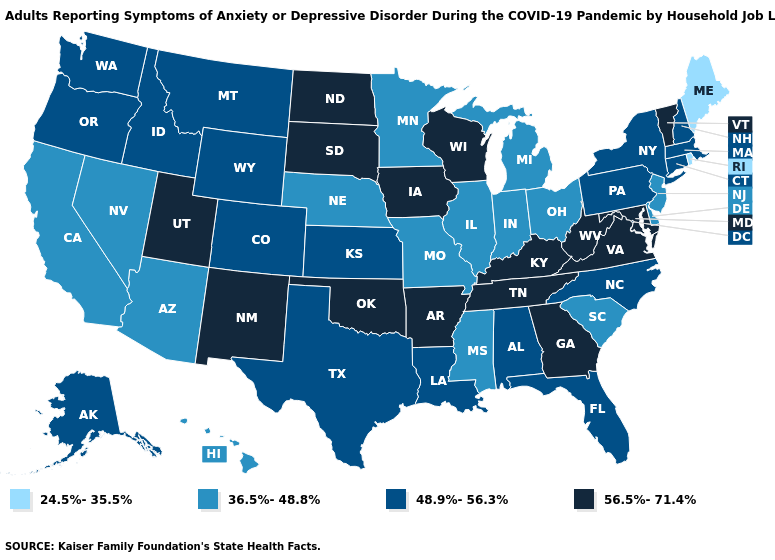What is the highest value in the USA?
Be succinct. 56.5%-71.4%. Name the states that have a value in the range 48.9%-56.3%?
Give a very brief answer. Alabama, Alaska, Colorado, Connecticut, Florida, Idaho, Kansas, Louisiana, Massachusetts, Montana, New Hampshire, New York, North Carolina, Oregon, Pennsylvania, Texas, Washington, Wyoming. Which states have the lowest value in the South?
Give a very brief answer. Delaware, Mississippi, South Carolina. Does the first symbol in the legend represent the smallest category?
Keep it brief. Yes. How many symbols are there in the legend?
Short answer required. 4. What is the highest value in the South ?
Give a very brief answer. 56.5%-71.4%. Name the states that have a value in the range 36.5%-48.8%?
Write a very short answer. Arizona, California, Delaware, Hawaii, Illinois, Indiana, Michigan, Minnesota, Mississippi, Missouri, Nebraska, Nevada, New Jersey, Ohio, South Carolina. Which states have the highest value in the USA?
Answer briefly. Arkansas, Georgia, Iowa, Kentucky, Maryland, New Mexico, North Dakota, Oklahoma, South Dakota, Tennessee, Utah, Vermont, Virginia, West Virginia, Wisconsin. Which states hav the highest value in the South?
Answer briefly. Arkansas, Georgia, Kentucky, Maryland, Oklahoma, Tennessee, Virginia, West Virginia. Does the map have missing data?
Keep it brief. No. Name the states that have a value in the range 48.9%-56.3%?
Quick response, please. Alabama, Alaska, Colorado, Connecticut, Florida, Idaho, Kansas, Louisiana, Massachusetts, Montana, New Hampshire, New York, North Carolina, Oregon, Pennsylvania, Texas, Washington, Wyoming. What is the value of Oklahoma?
Give a very brief answer. 56.5%-71.4%. Does New Jersey have the lowest value in the Northeast?
Give a very brief answer. No. Does New Jersey have the lowest value in the USA?
Be succinct. No. Name the states that have a value in the range 36.5%-48.8%?
Answer briefly. Arizona, California, Delaware, Hawaii, Illinois, Indiana, Michigan, Minnesota, Mississippi, Missouri, Nebraska, Nevada, New Jersey, Ohio, South Carolina. 